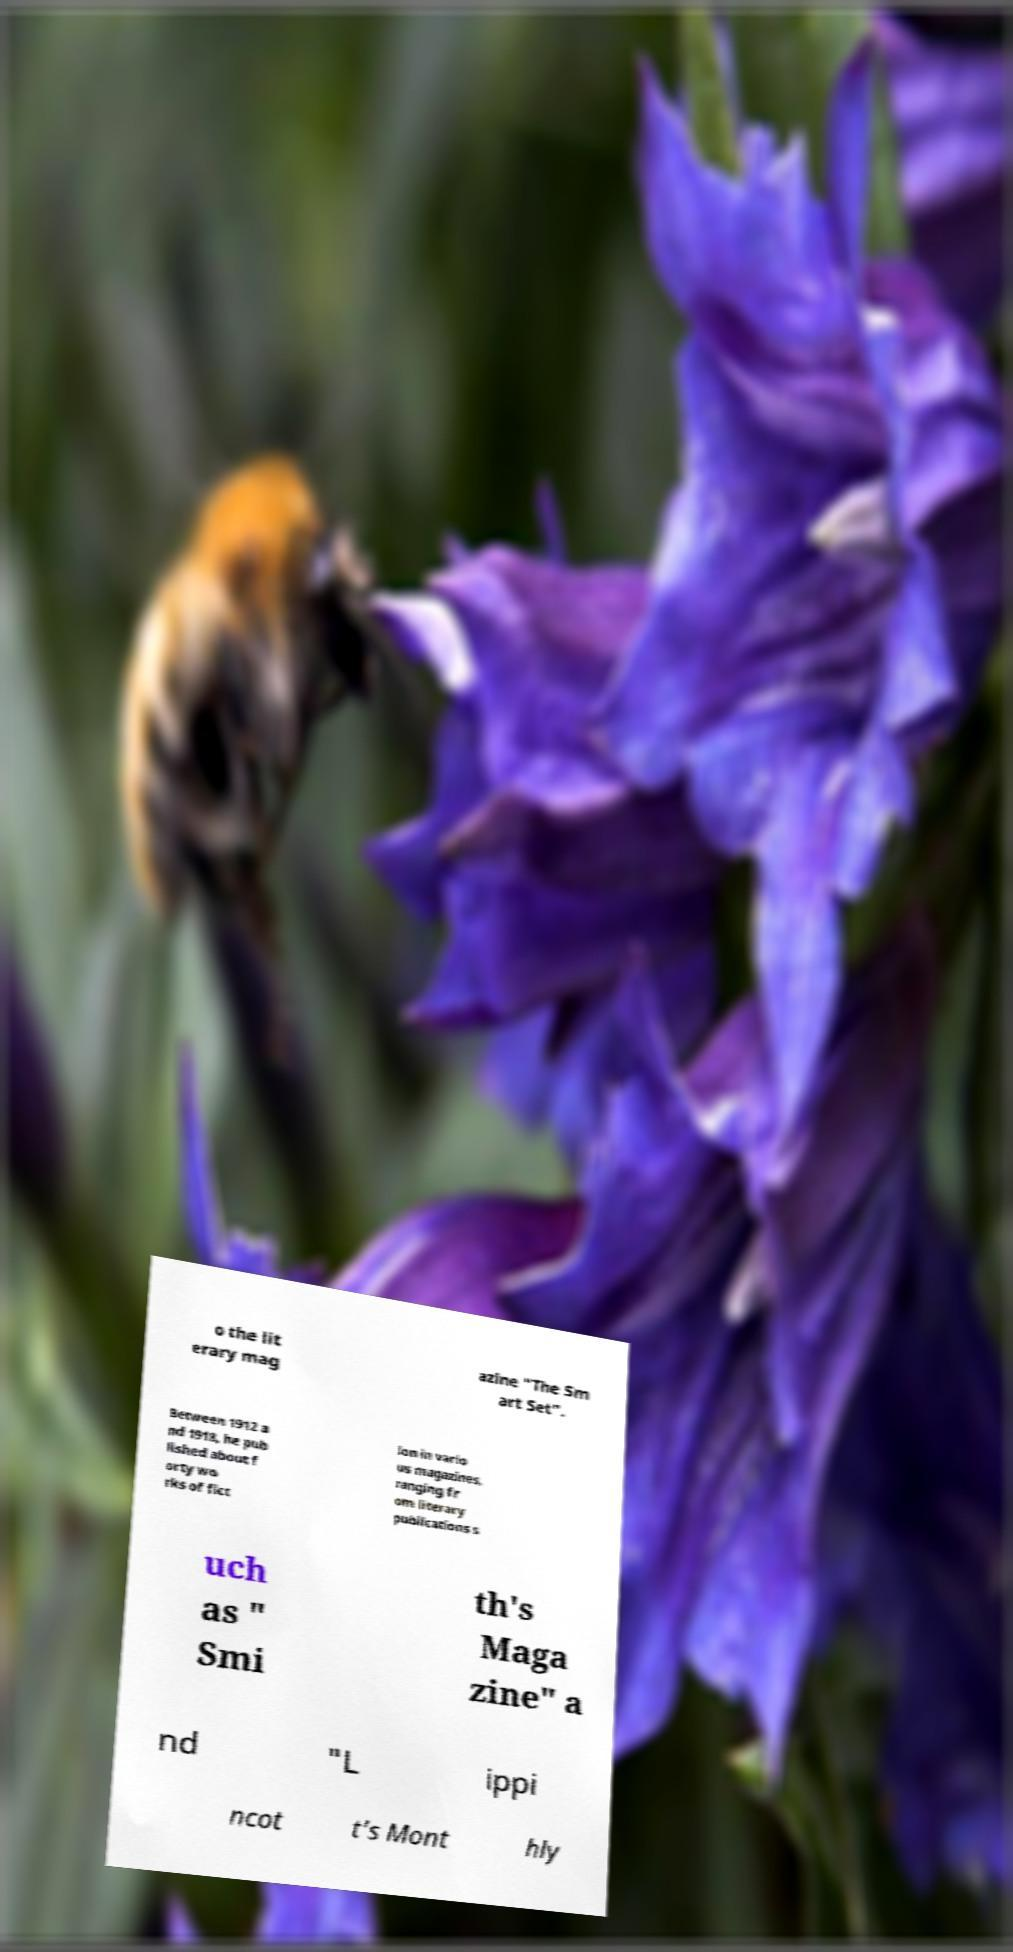Please identify and transcribe the text found in this image. o the lit erary mag azine "The Sm art Set". Between 1912 a nd 1918, he pub lished about f orty wo rks of fict ion in vario us magazines, ranging fr om literary publications s uch as " Smi th's Maga zine" a nd "L ippi ncot t's Mont hly 